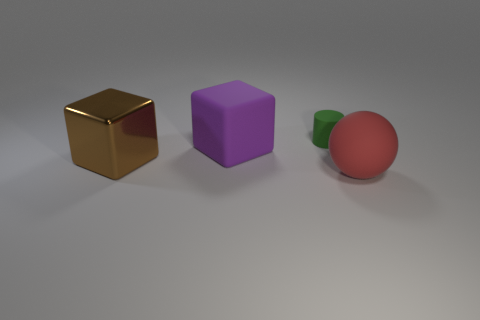There is a matte thing that is behind the big rubber object behind the large matte object that is right of the small matte object; what is its size?
Give a very brief answer. Small. How many things are either rubber cylinders or things right of the tiny green matte thing?
Make the answer very short. 2. What is the color of the cylinder?
Provide a succinct answer. Green. The large matte thing that is on the left side of the large matte sphere is what color?
Your answer should be compact. Purple. There is a big rubber thing to the right of the large rubber cube; what number of spheres are behind it?
Provide a short and direct response. 0. There is a brown cube; is it the same size as the block right of the big brown metal cube?
Keep it short and to the point. Yes. Are there any objects that have the same size as the red matte sphere?
Provide a succinct answer. Yes. How many things are tiny things or purple matte objects?
Your response must be concise. 2. There is a matte thing on the left side of the tiny matte thing; does it have the same size as the green rubber cylinder that is to the right of the purple block?
Provide a succinct answer. No. Is there another object of the same shape as the brown shiny object?
Offer a very short reply. Yes. 